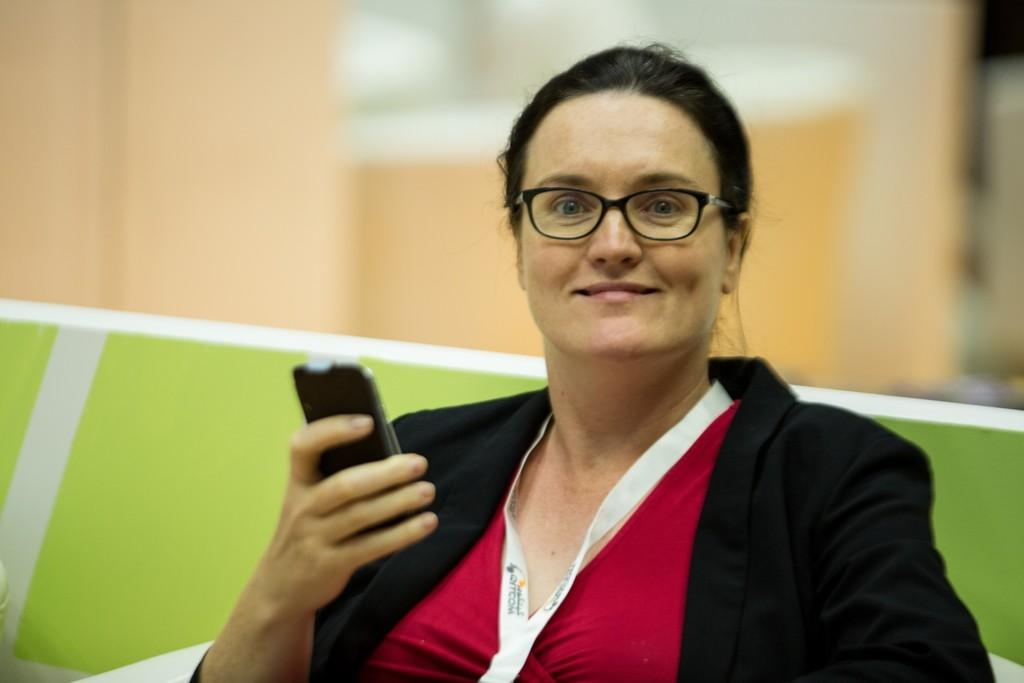What is the main subject of the image? The main subject of the image is a woman. What is the woman holding in her right hand? The woman is holding a mobile phone in her right hand. What is the woman wearing? The woman is wearing a suit. What is the woman's facial expression? The woman is smiling. What type of voyage is the woman embarking on in the image? There is no indication of a voyage in the image; it simply shows a woman holding a mobile phone and smiling. 